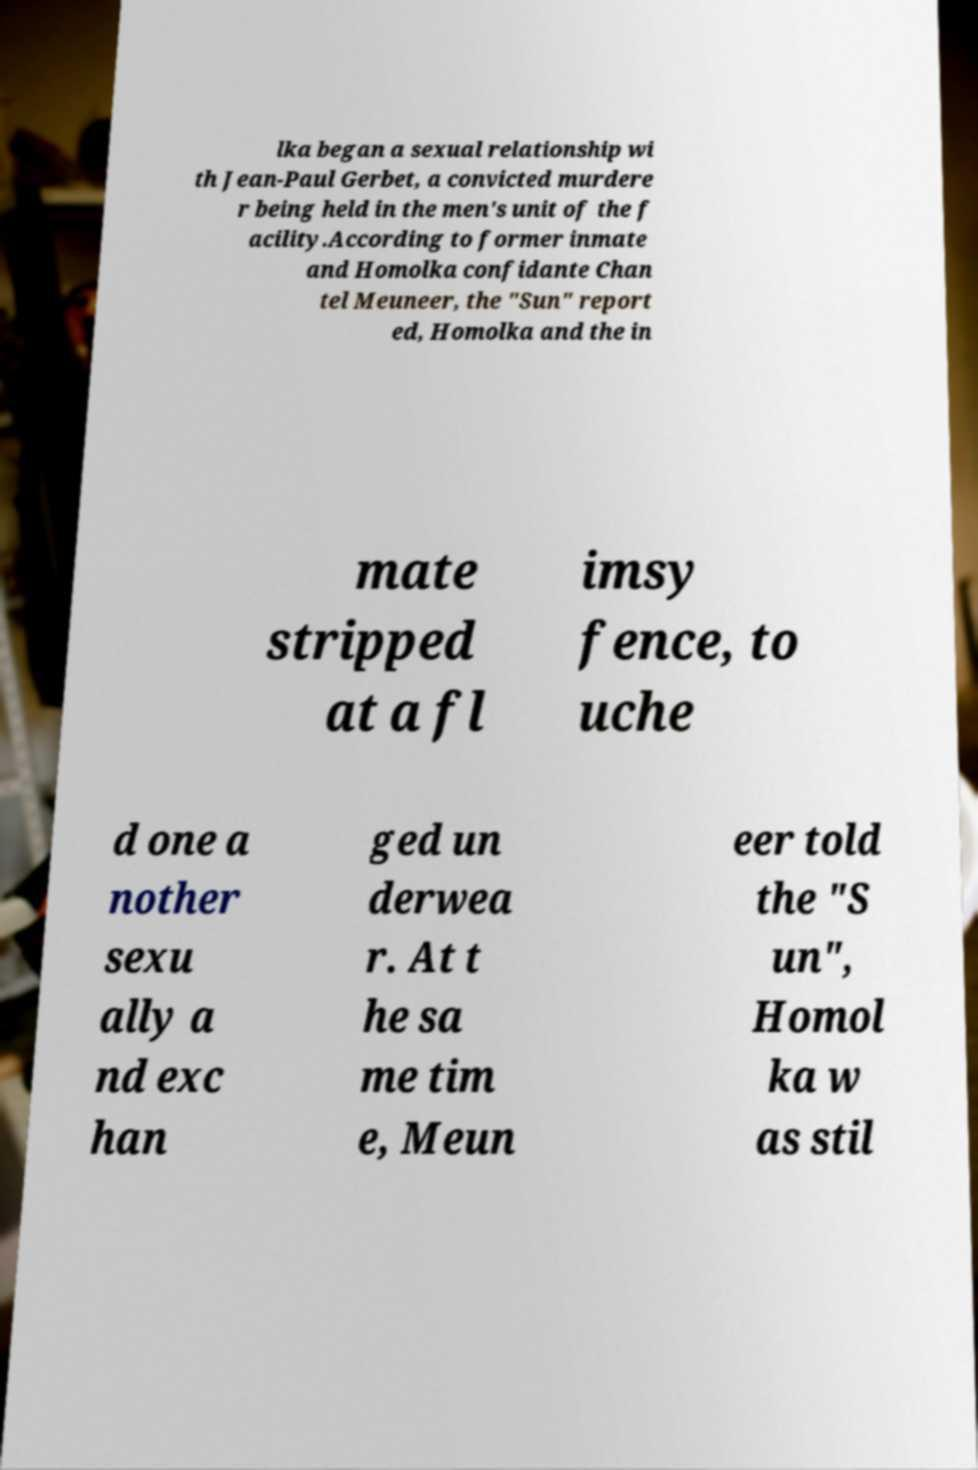What messages or text are displayed in this image? I need them in a readable, typed format. lka began a sexual relationship wi th Jean-Paul Gerbet, a convicted murdere r being held in the men's unit of the f acility.According to former inmate and Homolka confidante Chan tel Meuneer, the "Sun" report ed, Homolka and the in mate stripped at a fl imsy fence, to uche d one a nother sexu ally a nd exc han ged un derwea r. At t he sa me tim e, Meun eer told the "S un", Homol ka w as stil 